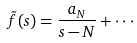Convert formula to latex. <formula><loc_0><loc_0><loc_500><loc_500>\tilde { f } ( s ) = \frac { a _ { N } } { s - N } + \cdot \cdot \cdot</formula> 